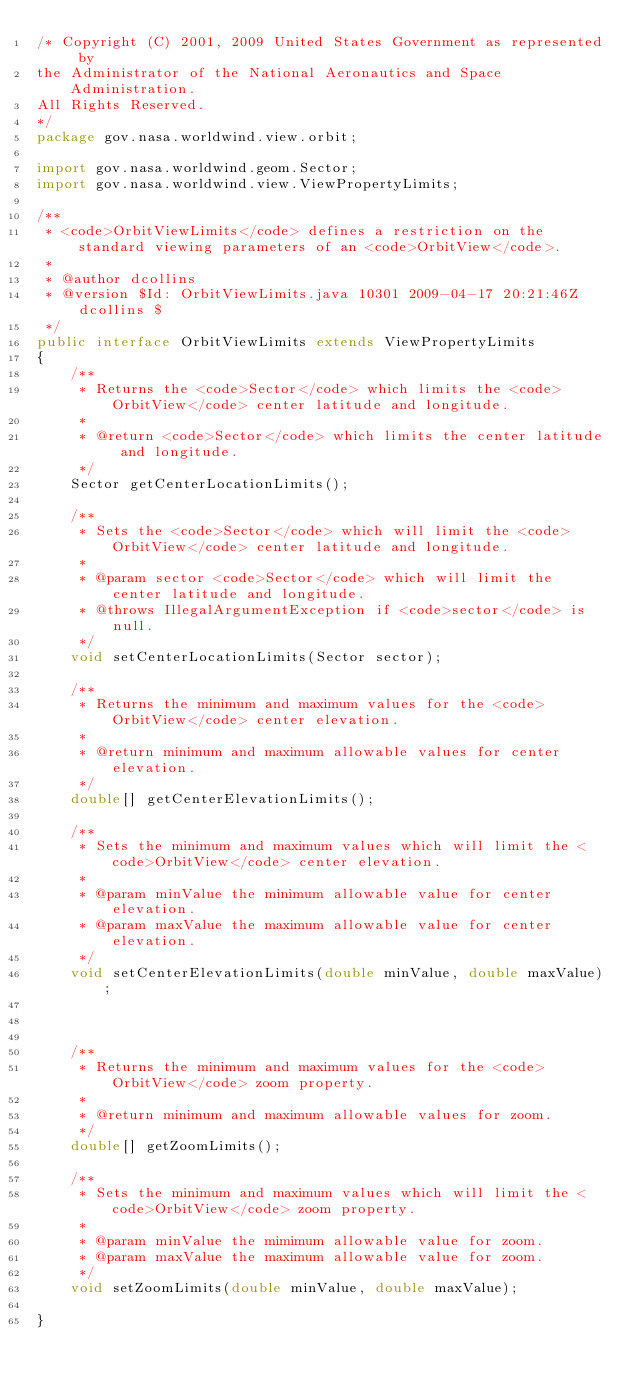<code> <loc_0><loc_0><loc_500><loc_500><_Java_>/* Copyright (C) 2001, 2009 United States Government as represented by
the Administrator of the National Aeronautics and Space Administration.
All Rights Reserved.
*/
package gov.nasa.worldwind.view.orbit;

import gov.nasa.worldwind.geom.Sector;
import gov.nasa.worldwind.view.ViewPropertyLimits;

/**
 * <code>OrbitViewLimits</code> defines a restriction on the standard viewing parameters of an <code>OrbitView</code>.
 *
 * @author dcollins
 * @version $Id: OrbitViewLimits.java 10301 2009-04-17 20:21:46Z dcollins $
 */
public interface OrbitViewLimits extends ViewPropertyLimits
{
    /**
     * Returns the <code>Sector</code> which limits the <code>OrbitView</code> center latitude and longitude.
     *
     * @return <code>Sector</code> which limits the center latitude and longitude.
     */
    Sector getCenterLocationLimits();

    /**
     * Sets the <code>Sector</code> which will limit the <code>OrbitView</code> center latitude and longitude.
     *
     * @param sector <code>Sector</code> which will limit the center latitude and longitude.
     * @throws IllegalArgumentException if <code>sector</code> is null.
     */
    void setCenterLocationLimits(Sector sector);

    /**
     * Returns the minimum and maximum values for the <code>OrbitView</code> center elevation.
     *
     * @return minimum and maximum allowable values for center elevation.
     */
    double[] getCenterElevationLimits();

    /**
     * Sets the minimum and maximum values which will limit the <code>OrbitView</code> center elevation.
     *
     * @param minValue the minimum allowable value for center elevation.
     * @param maxValue the maximum allowable value for center elevation.
     */
    void setCenterElevationLimits(double minValue, double maxValue);

    

    /**
     * Returns the minimum and maximum values for the <code>OrbitView</code> zoom property.
     *
     * @return minimum and maximum allowable values for zoom.
     */
    double[] getZoomLimits();

    /**
     * Sets the minimum and maximum values which will limit the <code>OrbitView</code> zoom property.
     *
     * @param minValue the mimimum allowable value for zoom.
     * @param maxValue the maximum allowable value for zoom.
     */
    void setZoomLimits(double minValue, double maxValue);

}
</code> 